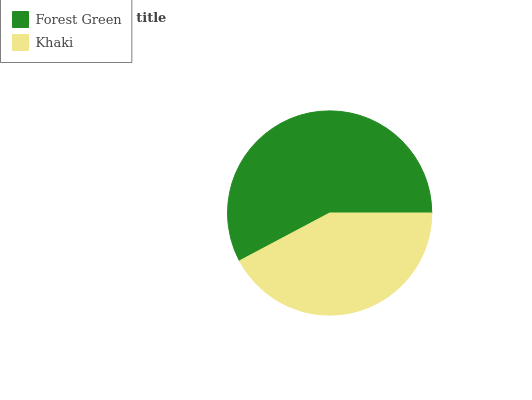Is Khaki the minimum?
Answer yes or no. Yes. Is Forest Green the maximum?
Answer yes or no. Yes. Is Khaki the maximum?
Answer yes or no. No. Is Forest Green greater than Khaki?
Answer yes or no. Yes. Is Khaki less than Forest Green?
Answer yes or no. Yes. Is Khaki greater than Forest Green?
Answer yes or no. No. Is Forest Green less than Khaki?
Answer yes or no. No. Is Forest Green the high median?
Answer yes or no. Yes. Is Khaki the low median?
Answer yes or no. Yes. Is Khaki the high median?
Answer yes or no. No. Is Forest Green the low median?
Answer yes or no. No. 